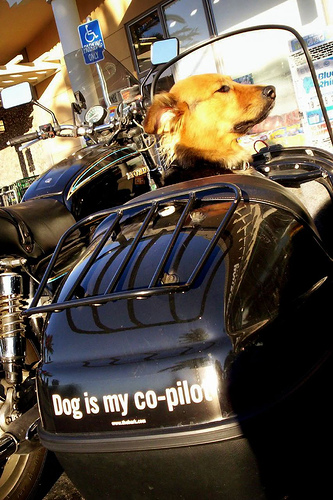Identify the text displayed in this image. Dog is my co-pilot 